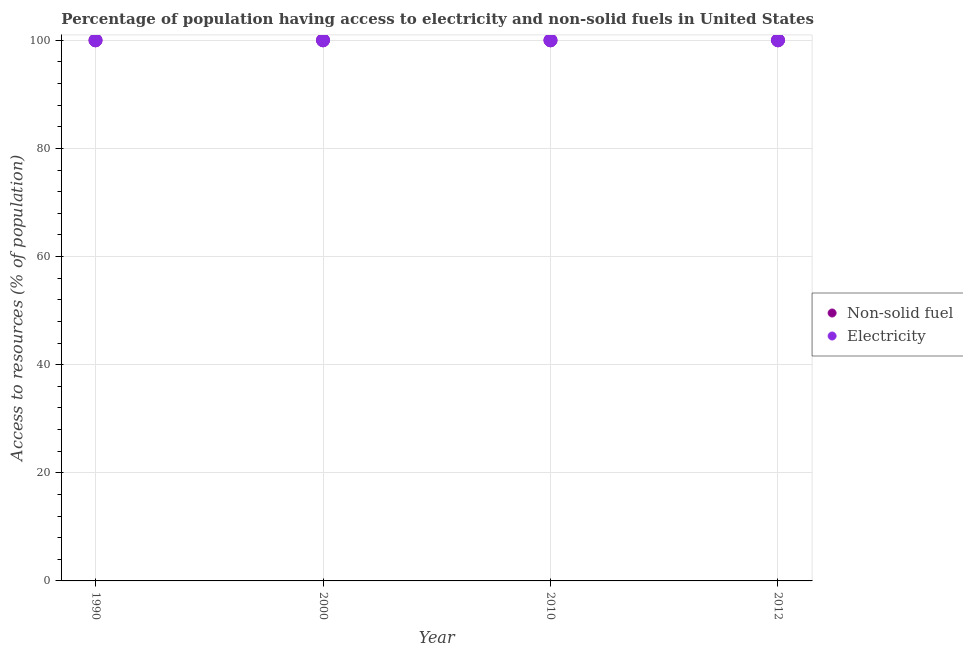How many different coloured dotlines are there?
Ensure brevity in your answer.  2. Is the number of dotlines equal to the number of legend labels?
Make the answer very short. Yes. What is the percentage of population having access to non-solid fuel in 2010?
Offer a terse response. 100. Across all years, what is the maximum percentage of population having access to electricity?
Your answer should be compact. 100. Across all years, what is the minimum percentage of population having access to non-solid fuel?
Provide a short and direct response. 100. In which year was the percentage of population having access to electricity minimum?
Provide a short and direct response. 1990. What is the total percentage of population having access to electricity in the graph?
Your answer should be very brief. 400. What is the difference between the percentage of population having access to electricity in 1990 and that in 2010?
Your response must be concise. 0. What is the average percentage of population having access to electricity per year?
Offer a terse response. 100. What is the ratio of the percentage of population having access to non-solid fuel in 2000 to that in 2010?
Your answer should be very brief. 1. Is the difference between the percentage of population having access to non-solid fuel in 1990 and 2012 greater than the difference between the percentage of population having access to electricity in 1990 and 2012?
Your response must be concise. No. What is the difference between the highest and the second highest percentage of population having access to electricity?
Offer a very short reply. 0. In how many years, is the percentage of population having access to electricity greater than the average percentage of population having access to electricity taken over all years?
Provide a succinct answer. 0. Does the percentage of population having access to electricity monotonically increase over the years?
Provide a short and direct response. No. Is the percentage of population having access to electricity strictly greater than the percentage of population having access to non-solid fuel over the years?
Ensure brevity in your answer.  No. How many dotlines are there?
Give a very brief answer. 2. How many years are there in the graph?
Your answer should be compact. 4. What is the difference between two consecutive major ticks on the Y-axis?
Your answer should be very brief. 20. Does the graph contain grids?
Provide a short and direct response. Yes. What is the title of the graph?
Give a very brief answer. Percentage of population having access to electricity and non-solid fuels in United States. Does "Underweight" appear as one of the legend labels in the graph?
Provide a short and direct response. No. What is the label or title of the Y-axis?
Offer a terse response. Access to resources (% of population). What is the Access to resources (% of population) in Non-solid fuel in 1990?
Make the answer very short. 100. What is the Access to resources (% of population) in Electricity in 1990?
Your response must be concise. 100. What is the Access to resources (% of population) in Non-solid fuel in 2000?
Keep it short and to the point. 100. What is the Access to resources (% of population) of Electricity in 2000?
Ensure brevity in your answer.  100. What is the Access to resources (% of population) in Non-solid fuel in 2012?
Your answer should be compact. 100. Across all years, what is the maximum Access to resources (% of population) in Electricity?
Offer a very short reply. 100. Across all years, what is the minimum Access to resources (% of population) of Electricity?
Your response must be concise. 100. What is the difference between the Access to resources (% of population) in Non-solid fuel in 1990 and that in 2012?
Provide a succinct answer. 0. What is the difference between the Access to resources (% of population) of Electricity in 2000 and that in 2010?
Make the answer very short. 0. What is the difference between the Access to resources (% of population) in Non-solid fuel in 2010 and that in 2012?
Give a very brief answer. 0. What is the difference between the Access to resources (% of population) of Non-solid fuel in 1990 and the Access to resources (% of population) of Electricity in 2000?
Your answer should be compact. 0. What is the difference between the Access to resources (% of population) in Non-solid fuel in 1990 and the Access to resources (% of population) in Electricity in 2010?
Your response must be concise. 0. What is the difference between the Access to resources (% of population) of Non-solid fuel in 1990 and the Access to resources (% of population) of Electricity in 2012?
Keep it short and to the point. 0. What is the difference between the Access to resources (% of population) in Non-solid fuel in 2000 and the Access to resources (% of population) in Electricity in 2012?
Your response must be concise. 0. What is the average Access to resources (% of population) of Non-solid fuel per year?
Ensure brevity in your answer.  100. What is the average Access to resources (% of population) of Electricity per year?
Your response must be concise. 100. In the year 2000, what is the difference between the Access to resources (% of population) of Non-solid fuel and Access to resources (% of population) of Electricity?
Offer a very short reply. 0. In the year 2010, what is the difference between the Access to resources (% of population) of Non-solid fuel and Access to resources (% of population) of Electricity?
Offer a very short reply. 0. What is the ratio of the Access to resources (% of population) of Non-solid fuel in 1990 to that in 2010?
Offer a terse response. 1. What is the ratio of the Access to resources (% of population) in Electricity in 1990 to that in 2010?
Provide a succinct answer. 1. What is the ratio of the Access to resources (% of population) in Electricity in 1990 to that in 2012?
Provide a short and direct response. 1. What is the ratio of the Access to resources (% of population) of Non-solid fuel in 2000 to that in 2012?
Make the answer very short. 1. What is the ratio of the Access to resources (% of population) of Electricity in 2000 to that in 2012?
Provide a succinct answer. 1. What is the ratio of the Access to resources (% of population) of Non-solid fuel in 2010 to that in 2012?
Ensure brevity in your answer.  1. What is the difference between the highest and the second highest Access to resources (% of population) of Electricity?
Provide a succinct answer. 0. 